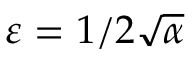<formula> <loc_0><loc_0><loc_500><loc_500>\varepsilon = 1 / 2 \sqrt { \alpha }</formula> 